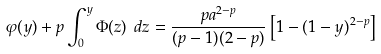<formula> <loc_0><loc_0><loc_500><loc_500>\varphi ( y ) + p \int _ { 0 } ^ { y } \Phi ( z ) \ d z = \frac { p a ^ { 2 - p } } { ( p - 1 ) ( 2 - p ) } \left [ 1 - ( 1 - y ) ^ { 2 - p } \right ]</formula> 